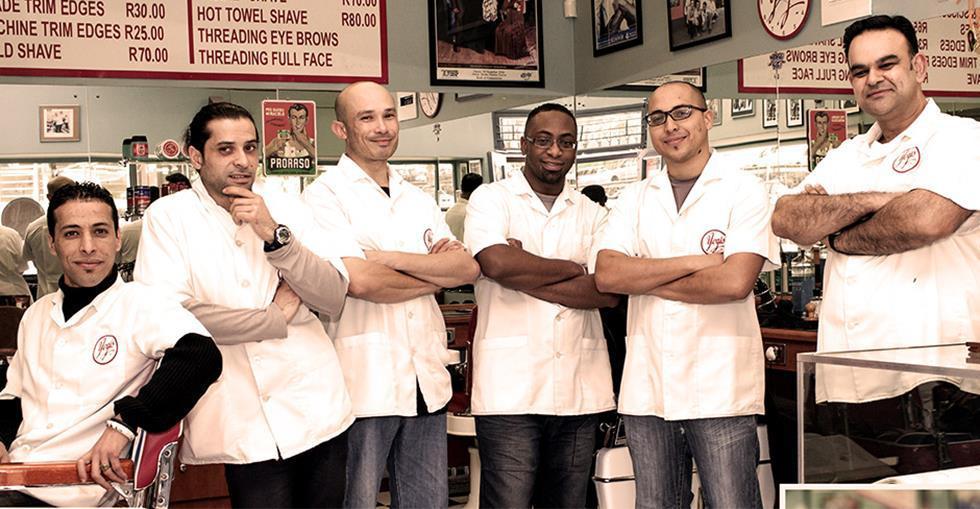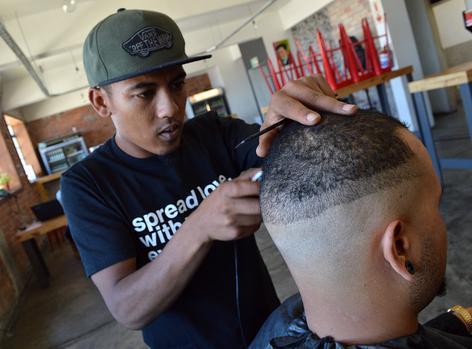The first image is the image on the left, the second image is the image on the right. For the images displayed, is the sentence "One image shows hair stylists posing with folded arms, without customers." factually correct? Answer yes or no. Yes. The first image is the image on the left, the second image is the image on the right. Evaluate the accuracy of this statement regarding the images: "Barber stylists stand with their arms crossed in one image, while a patron receives a barbershop service in the other image.". Is it true? Answer yes or no. Yes. 